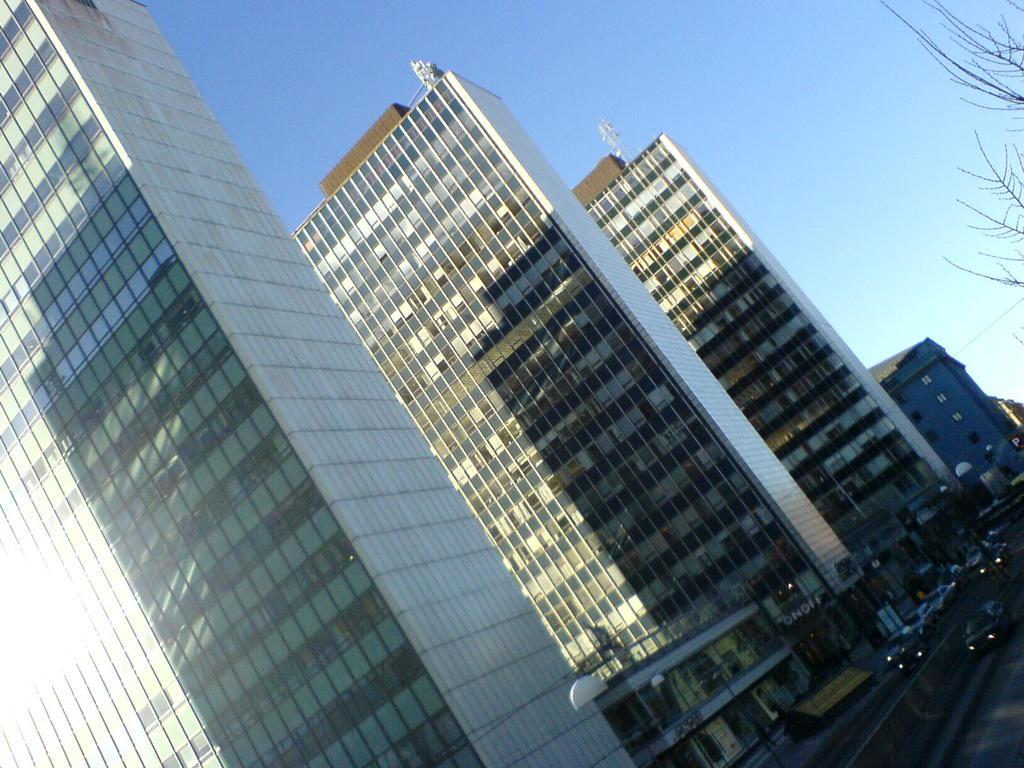What type of structures can be seen in the image? There are buildings in the image. What is happening on the road in the image? There are vehicles on the road in the image. What type of vegetation is present in the image? There are trees in the image. What else can be seen in the image besides buildings and trees? There are poles in the image. What is visible in the background of the image? The sky is visible in the background of the image. What type of prose can be heard being read aloud in the image? There is no indication of any prose being read aloud in the image. What type of acoustics can be observed in the image? The image does not provide any information about acoustics. 